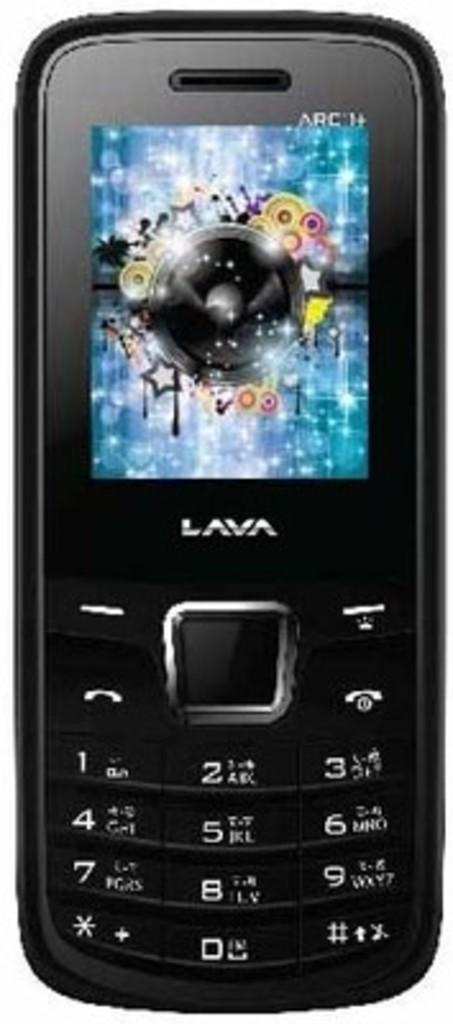What can be seen hanging in the image? There is a mobile in the image. What might be the purpose of the mobile in the image? The mobile might be decorative or serve as a toy for a baby. Can you describe the design or appearance of the mobile? Unfortunately, the design or appearance of the mobile cannot be determined from the provided fact. How many rabbits are sitting on the straw in the image? There are no rabbits or straw present in the image; only a mobile is mentioned. 